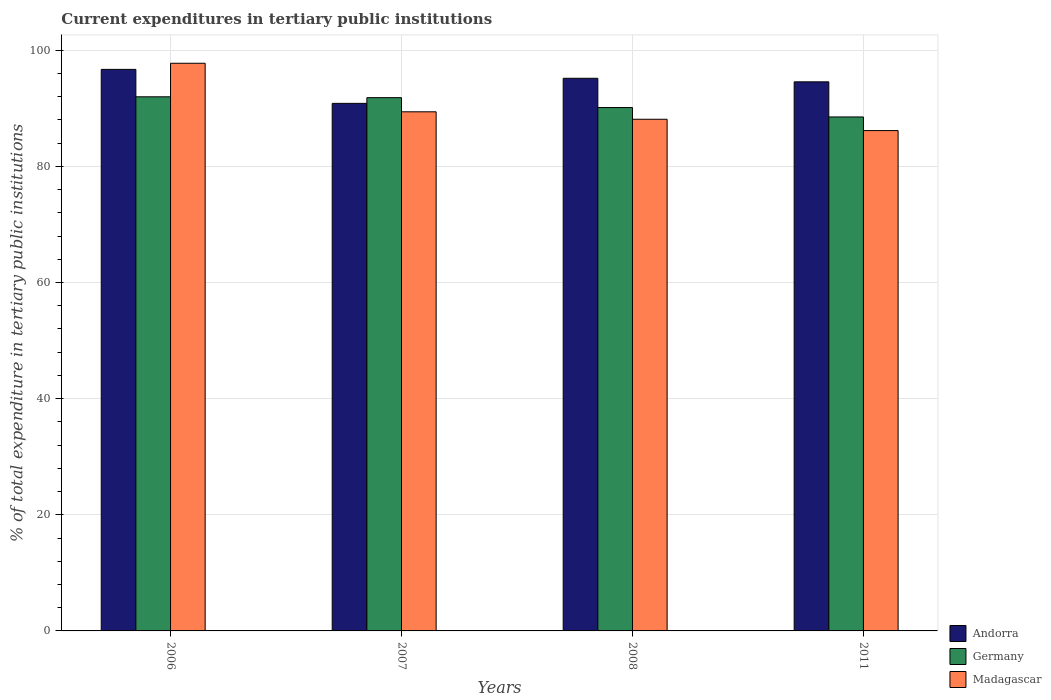How many different coloured bars are there?
Provide a succinct answer. 3. Are the number of bars on each tick of the X-axis equal?
Provide a succinct answer. Yes. How many bars are there on the 1st tick from the left?
Provide a short and direct response. 3. How many bars are there on the 3rd tick from the right?
Provide a short and direct response. 3. What is the current expenditures in tertiary public institutions in Madagascar in 2006?
Provide a succinct answer. 97.75. Across all years, what is the maximum current expenditures in tertiary public institutions in Germany?
Keep it short and to the point. 91.97. Across all years, what is the minimum current expenditures in tertiary public institutions in Germany?
Ensure brevity in your answer.  88.5. What is the total current expenditures in tertiary public institutions in Andorra in the graph?
Your response must be concise. 377.25. What is the difference between the current expenditures in tertiary public institutions in Andorra in 2007 and that in 2011?
Provide a succinct answer. -3.71. What is the difference between the current expenditures in tertiary public institutions in Andorra in 2008 and the current expenditures in tertiary public institutions in Madagascar in 2007?
Your answer should be very brief. 5.77. What is the average current expenditures in tertiary public institutions in Andorra per year?
Keep it short and to the point. 94.31. In the year 2006, what is the difference between the current expenditures in tertiary public institutions in Madagascar and current expenditures in tertiary public institutions in Germany?
Your response must be concise. 5.78. What is the ratio of the current expenditures in tertiary public institutions in Andorra in 2006 to that in 2008?
Make the answer very short. 1.02. Is the current expenditures in tertiary public institutions in Andorra in 2007 less than that in 2008?
Offer a very short reply. Yes. Is the difference between the current expenditures in tertiary public institutions in Madagascar in 2006 and 2007 greater than the difference between the current expenditures in tertiary public institutions in Germany in 2006 and 2007?
Your answer should be compact. Yes. What is the difference between the highest and the second highest current expenditures in tertiary public institutions in Germany?
Make the answer very short. 0.15. What is the difference between the highest and the lowest current expenditures in tertiary public institutions in Germany?
Ensure brevity in your answer.  3.47. In how many years, is the current expenditures in tertiary public institutions in Madagascar greater than the average current expenditures in tertiary public institutions in Madagascar taken over all years?
Your answer should be compact. 1. What does the 2nd bar from the left in 2006 represents?
Keep it short and to the point. Germany. Is it the case that in every year, the sum of the current expenditures in tertiary public institutions in Germany and current expenditures in tertiary public institutions in Madagascar is greater than the current expenditures in tertiary public institutions in Andorra?
Give a very brief answer. Yes. How many years are there in the graph?
Provide a succinct answer. 4. Are the values on the major ticks of Y-axis written in scientific E-notation?
Provide a succinct answer. No. How many legend labels are there?
Your answer should be very brief. 3. How are the legend labels stacked?
Provide a short and direct response. Vertical. What is the title of the graph?
Provide a succinct answer. Current expenditures in tertiary public institutions. What is the label or title of the X-axis?
Your answer should be compact. Years. What is the label or title of the Y-axis?
Offer a terse response. % of total expenditure in tertiary public institutions. What is the % of total expenditure in tertiary public institutions in Andorra in 2006?
Keep it short and to the point. 96.7. What is the % of total expenditure in tertiary public institutions in Germany in 2006?
Your response must be concise. 91.97. What is the % of total expenditure in tertiary public institutions of Madagascar in 2006?
Provide a short and direct response. 97.75. What is the % of total expenditure in tertiary public institutions of Andorra in 2007?
Offer a terse response. 90.84. What is the % of total expenditure in tertiary public institutions in Germany in 2007?
Give a very brief answer. 91.83. What is the % of total expenditure in tertiary public institutions of Madagascar in 2007?
Provide a short and direct response. 89.39. What is the % of total expenditure in tertiary public institutions of Andorra in 2008?
Keep it short and to the point. 95.16. What is the % of total expenditure in tertiary public institutions in Germany in 2008?
Your response must be concise. 90.12. What is the % of total expenditure in tertiary public institutions of Madagascar in 2008?
Provide a succinct answer. 88.11. What is the % of total expenditure in tertiary public institutions in Andorra in 2011?
Provide a short and direct response. 94.55. What is the % of total expenditure in tertiary public institutions in Germany in 2011?
Provide a short and direct response. 88.5. What is the % of total expenditure in tertiary public institutions in Madagascar in 2011?
Make the answer very short. 86.16. Across all years, what is the maximum % of total expenditure in tertiary public institutions in Andorra?
Offer a very short reply. 96.7. Across all years, what is the maximum % of total expenditure in tertiary public institutions of Germany?
Ensure brevity in your answer.  91.97. Across all years, what is the maximum % of total expenditure in tertiary public institutions in Madagascar?
Ensure brevity in your answer.  97.75. Across all years, what is the minimum % of total expenditure in tertiary public institutions of Andorra?
Keep it short and to the point. 90.84. Across all years, what is the minimum % of total expenditure in tertiary public institutions in Germany?
Provide a succinct answer. 88.5. Across all years, what is the minimum % of total expenditure in tertiary public institutions in Madagascar?
Give a very brief answer. 86.16. What is the total % of total expenditure in tertiary public institutions of Andorra in the graph?
Give a very brief answer. 377.25. What is the total % of total expenditure in tertiary public institutions in Germany in the graph?
Your answer should be compact. 362.42. What is the total % of total expenditure in tertiary public institutions in Madagascar in the graph?
Give a very brief answer. 361.41. What is the difference between the % of total expenditure in tertiary public institutions in Andorra in 2006 and that in 2007?
Make the answer very short. 5.85. What is the difference between the % of total expenditure in tertiary public institutions in Germany in 2006 and that in 2007?
Your answer should be compact. 0.15. What is the difference between the % of total expenditure in tertiary public institutions of Madagascar in 2006 and that in 2007?
Keep it short and to the point. 8.36. What is the difference between the % of total expenditure in tertiary public institutions of Andorra in 2006 and that in 2008?
Offer a very short reply. 1.54. What is the difference between the % of total expenditure in tertiary public institutions in Germany in 2006 and that in 2008?
Give a very brief answer. 1.85. What is the difference between the % of total expenditure in tertiary public institutions in Madagascar in 2006 and that in 2008?
Provide a short and direct response. 9.64. What is the difference between the % of total expenditure in tertiary public institutions of Andorra in 2006 and that in 2011?
Make the answer very short. 2.15. What is the difference between the % of total expenditure in tertiary public institutions in Germany in 2006 and that in 2011?
Make the answer very short. 3.47. What is the difference between the % of total expenditure in tertiary public institutions of Madagascar in 2006 and that in 2011?
Offer a very short reply. 11.59. What is the difference between the % of total expenditure in tertiary public institutions in Andorra in 2007 and that in 2008?
Ensure brevity in your answer.  -4.32. What is the difference between the % of total expenditure in tertiary public institutions of Germany in 2007 and that in 2008?
Provide a succinct answer. 1.7. What is the difference between the % of total expenditure in tertiary public institutions of Madagascar in 2007 and that in 2008?
Offer a very short reply. 1.28. What is the difference between the % of total expenditure in tertiary public institutions of Andorra in 2007 and that in 2011?
Offer a terse response. -3.71. What is the difference between the % of total expenditure in tertiary public institutions in Germany in 2007 and that in 2011?
Offer a very short reply. 3.32. What is the difference between the % of total expenditure in tertiary public institutions of Madagascar in 2007 and that in 2011?
Your response must be concise. 3.23. What is the difference between the % of total expenditure in tertiary public institutions in Andorra in 2008 and that in 2011?
Your answer should be compact. 0.61. What is the difference between the % of total expenditure in tertiary public institutions of Germany in 2008 and that in 2011?
Provide a short and direct response. 1.62. What is the difference between the % of total expenditure in tertiary public institutions of Madagascar in 2008 and that in 2011?
Give a very brief answer. 1.95. What is the difference between the % of total expenditure in tertiary public institutions in Andorra in 2006 and the % of total expenditure in tertiary public institutions in Germany in 2007?
Provide a succinct answer. 4.87. What is the difference between the % of total expenditure in tertiary public institutions of Andorra in 2006 and the % of total expenditure in tertiary public institutions of Madagascar in 2007?
Your response must be concise. 7.3. What is the difference between the % of total expenditure in tertiary public institutions of Germany in 2006 and the % of total expenditure in tertiary public institutions of Madagascar in 2007?
Provide a succinct answer. 2.58. What is the difference between the % of total expenditure in tertiary public institutions of Andorra in 2006 and the % of total expenditure in tertiary public institutions of Germany in 2008?
Provide a succinct answer. 6.57. What is the difference between the % of total expenditure in tertiary public institutions of Andorra in 2006 and the % of total expenditure in tertiary public institutions of Madagascar in 2008?
Offer a very short reply. 8.59. What is the difference between the % of total expenditure in tertiary public institutions in Germany in 2006 and the % of total expenditure in tertiary public institutions in Madagascar in 2008?
Offer a very short reply. 3.87. What is the difference between the % of total expenditure in tertiary public institutions of Andorra in 2006 and the % of total expenditure in tertiary public institutions of Germany in 2011?
Keep it short and to the point. 8.19. What is the difference between the % of total expenditure in tertiary public institutions of Andorra in 2006 and the % of total expenditure in tertiary public institutions of Madagascar in 2011?
Make the answer very short. 10.54. What is the difference between the % of total expenditure in tertiary public institutions in Germany in 2006 and the % of total expenditure in tertiary public institutions in Madagascar in 2011?
Offer a terse response. 5.82. What is the difference between the % of total expenditure in tertiary public institutions in Andorra in 2007 and the % of total expenditure in tertiary public institutions in Germany in 2008?
Your answer should be very brief. 0.72. What is the difference between the % of total expenditure in tertiary public institutions of Andorra in 2007 and the % of total expenditure in tertiary public institutions of Madagascar in 2008?
Provide a succinct answer. 2.74. What is the difference between the % of total expenditure in tertiary public institutions of Germany in 2007 and the % of total expenditure in tertiary public institutions of Madagascar in 2008?
Your answer should be very brief. 3.72. What is the difference between the % of total expenditure in tertiary public institutions of Andorra in 2007 and the % of total expenditure in tertiary public institutions of Germany in 2011?
Keep it short and to the point. 2.34. What is the difference between the % of total expenditure in tertiary public institutions in Andorra in 2007 and the % of total expenditure in tertiary public institutions in Madagascar in 2011?
Your response must be concise. 4.69. What is the difference between the % of total expenditure in tertiary public institutions in Germany in 2007 and the % of total expenditure in tertiary public institutions in Madagascar in 2011?
Offer a terse response. 5.67. What is the difference between the % of total expenditure in tertiary public institutions in Andorra in 2008 and the % of total expenditure in tertiary public institutions in Germany in 2011?
Give a very brief answer. 6.66. What is the difference between the % of total expenditure in tertiary public institutions in Andorra in 2008 and the % of total expenditure in tertiary public institutions in Madagascar in 2011?
Your response must be concise. 9. What is the difference between the % of total expenditure in tertiary public institutions in Germany in 2008 and the % of total expenditure in tertiary public institutions in Madagascar in 2011?
Make the answer very short. 3.96. What is the average % of total expenditure in tertiary public institutions in Andorra per year?
Your answer should be very brief. 94.31. What is the average % of total expenditure in tertiary public institutions in Germany per year?
Make the answer very short. 90.61. What is the average % of total expenditure in tertiary public institutions in Madagascar per year?
Ensure brevity in your answer.  90.35. In the year 2006, what is the difference between the % of total expenditure in tertiary public institutions of Andorra and % of total expenditure in tertiary public institutions of Germany?
Offer a very short reply. 4.72. In the year 2006, what is the difference between the % of total expenditure in tertiary public institutions of Andorra and % of total expenditure in tertiary public institutions of Madagascar?
Keep it short and to the point. -1.05. In the year 2006, what is the difference between the % of total expenditure in tertiary public institutions in Germany and % of total expenditure in tertiary public institutions in Madagascar?
Keep it short and to the point. -5.78. In the year 2007, what is the difference between the % of total expenditure in tertiary public institutions in Andorra and % of total expenditure in tertiary public institutions in Germany?
Offer a terse response. -0.98. In the year 2007, what is the difference between the % of total expenditure in tertiary public institutions in Andorra and % of total expenditure in tertiary public institutions in Madagascar?
Ensure brevity in your answer.  1.45. In the year 2007, what is the difference between the % of total expenditure in tertiary public institutions in Germany and % of total expenditure in tertiary public institutions in Madagascar?
Your response must be concise. 2.43. In the year 2008, what is the difference between the % of total expenditure in tertiary public institutions in Andorra and % of total expenditure in tertiary public institutions in Germany?
Provide a succinct answer. 5.04. In the year 2008, what is the difference between the % of total expenditure in tertiary public institutions in Andorra and % of total expenditure in tertiary public institutions in Madagascar?
Provide a succinct answer. 7.05. In the year 2008, what is the difference between the % of total expenditure in tertiary public institutions in Germany and % of total expenditure in tertiary public institutions in Madagascar?
Your response must be concise. 2.01. In the year 2011, what is the difference between the % of total expenditure in tertiary public institutions in Andorra and % of total expenditure in tertiary public institutions in Germany?
Offer a terse response. 6.05. In the year 2011, what is the difference between the % of total expenditure in tertiary public institutions of Andorra and % of total expenditure in tertiary public institutions of Madagascar?
Offer a very short reply. 8.39. In the year 2011, what is the difference between the % of total expenditure in tertiary public institutions of Germany and % of total expenditure in tertiary public institutions of Madagascar?
Ensure brevity in your answer.  2.35. What is the ratio of the % of total expenditure in tertiary public institutions of Andorra in 2006 to that in 2007?
Your response must be concise. 1.06. What is the ratio of the % of total expenditure in tertiary public institutions in Madagascar in 2006 to that in 2007?
Ensure brevity in your answer.  1.09. What is the ratio of the % of total expenditure in tertiary public institutions in Andorra in 2006 to that in 2008?
Your answer should be compact. 1.02. What is the ratio of the % of total expenditure in tertiary public institutions in Germany in 2006 to that in 2008?
Provide a short and direct response. 1.02. What is the ratio of the % of total expenditure in tertiary public institutions of Madagascar in 2006 to that in 2008?
Provide a short and direct response. 1.11. What is the ratio of the % of total expenditure in tertiary public institutions of Andorra in 2006 to that in 2011?
Provide a succinct answer. 1.02. What is the ratio of the % of total expenditure in tertiary public institutions of Germany in 2006 to that in 2011?
Make the answer very short. 1.04. What is the ratio of the % of total expenditure in tertiary public institutions in Madagascar in 2006 to that in 2011?
Give a very brief answer. 1.13. What is the ratio of the % of total expenditure in tertiary public institutions in Andorra in 2007 to that in 2008?
Give a very brief answer. 0.95. What is the ratio of the % of total expenditure in tertiary public institutions of Germany in 2007 to that in 2008?
Your answer should be very brief. 1.02. What is the ratio of the % of total expenditure in tertiary public institutions in Madagascar in 2007 to that in 2008?
Your answer should be compact. 1.01. What is the ratio of the % of total expenditure in tertiary public institutions of Andorra in 2007 to that in 2011?
Offer a very short reply. 0.96. What is the ratio of the % of total expenditure in tertiary public institutions of Germany in 2007 to that in 2011?
Keep it short and to the point. 1.04. What is the ratio of the % of total expenditure in tertiary public institutions of Madagascar in 2007 to that in 2011?
Give a very brief answer. 1.04. What is the ratio of the % of total expenditure in tertiary public institutions of Andorra in 2008 to that in 2011?
Offer a terse response. 1.01. What is the ratio of the % of total expenditure in tertiary public institutions in Germany in 2008 to that in 2011?
Ensure brevity in your answer.  1.02. What is the ratio of the % of total expenditure in tertiary public institutions of Madagascar in 2008 to that in 2011?
Your answer should be compact. 1.02. What is the difference between the highest and the second highest % of total expenditure in tertiary public institutions in Andorra?
Your answer should be very brief. 1.54. What is the difference between the highest and the second highest % of total expenditure in tertiary public institutions of Germany?
Ensure brevity in your answer.  0.15. What is the difference between the highest and the second highest % of total expenditure in tertiary public institutions in Madagascar?
Provide a succinct answer. 8.36. What is the difference between the highest and the lowest % of total expenditure in tertiary public institutions of Andorra?
Make the answer very short. 5.85. What is the difference between the highest and the lowest % of total expenditure in tertiary public institutions in Germany?
Provide a succinct answer. 3.47. What is the difference between the highest and the lowest % of total expenditure in tertiary public institutions of Madagascar?
Your response must be concise. 11.59. 